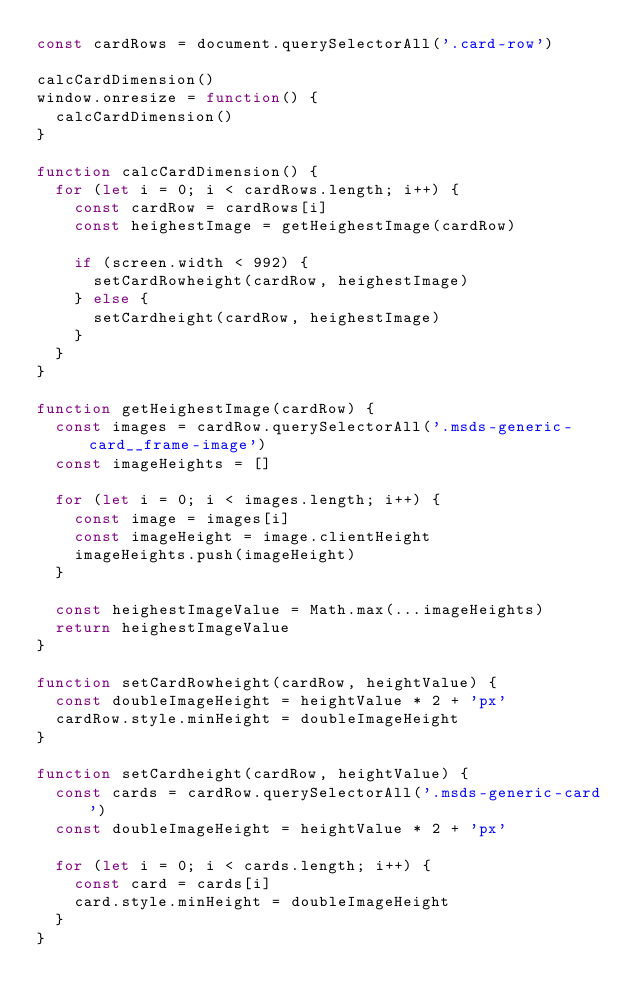Convert code to text. <code><loc_0><loc_0><loc_500><loc_500><_JavaScript_>const cardRows = document.querySelectorAll('.card-row')

calcCardDimension()
window.onresize = function() {
  calcCardDimension()
}

function calcCardDimension() {
  for (let i = 0; i < cardRows.length; i++) {
    const cardRow = cardRows[i]
    const heighestImage = getHeighestImage(cardRow)

    if (screen.width < 992) {
      setCardRowheight(cardRow, heighestImage)
    } else {
      setCardheight(cardRow, heighestImage)
    }
  }
}

function getHeighestImage(cardRow) {
  const images = cardRow.querySelectorAll('.msds-generic-card__frame-image')
  const imageHeights = []

  for (let i = 0; i < images.length; i++) {
    const image = images[i]
    const imageHeight = image.clientHeight
    imageHeights.push(imageHeight)
  }

  const heighestImageValue = Math.max(...imageHeights)
  return heighestImageValue
}

function setCardRowheight(cardRow, heightValue) {
  const doubleImageHeight = heightValue * 2 + 'px'
  cardRow.style.minHeight = doubleImageHeight
}

function setCardheight(cardRow, heightValue) {
  const cards = cardRow.querySelectorAll('.msds-generic-card')
  const doubleImageHeight = heightValue * 2 + 'px'

  for (let i = 0; i < cards.length; i++) {
    const card = cards[i]
    card.style.minHeight = doubleImageHeight
  }
}
</code> 